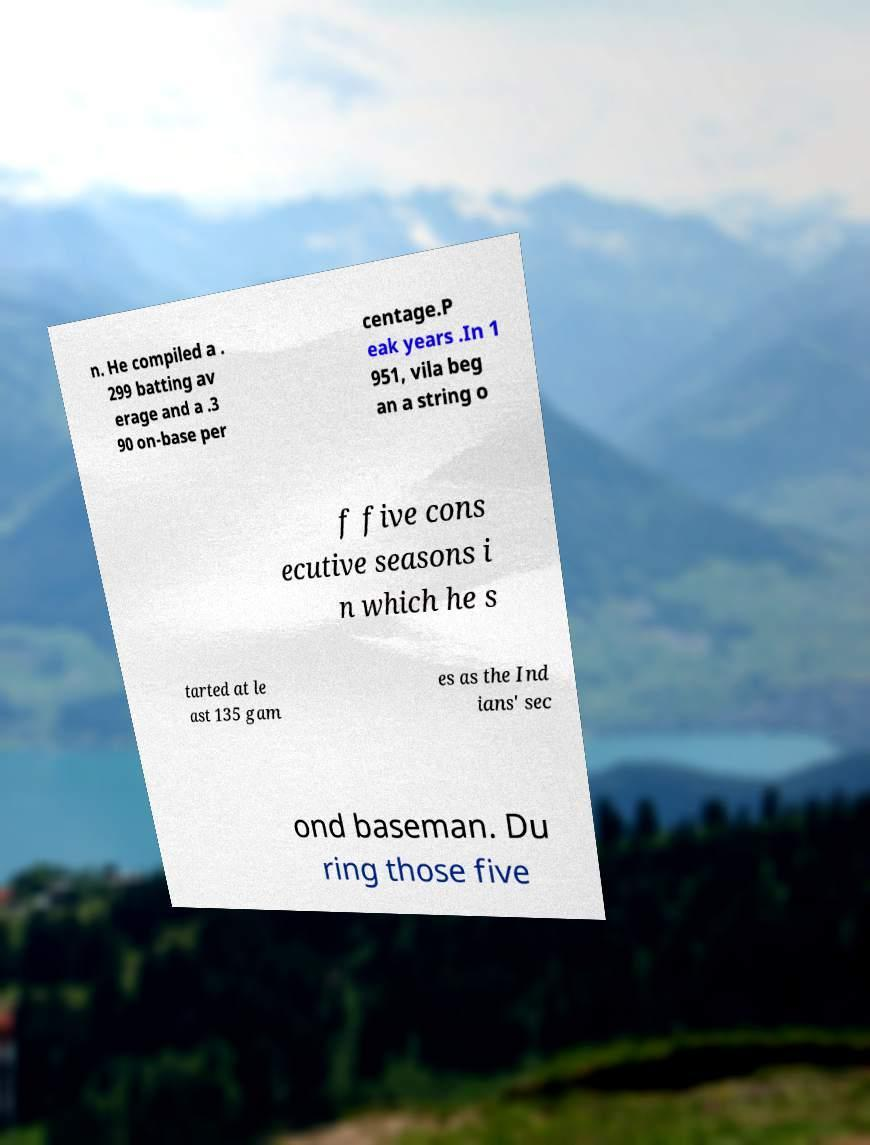Could you assist in decoding the text presented in this image and type it out clearly? n. He compiled a . 299 batting av erage and a .3 90 on-base per centage.P eak years .In 1 951, vila beg an a string o f five cons ecutive seasons i n which he s tarted at le ast 135 gam es as the Ind ians' sec ond baseman. Du ring those five 